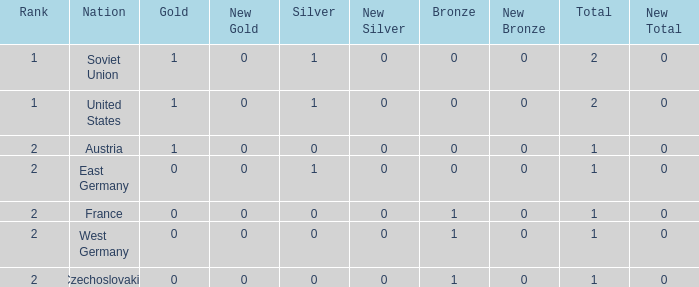What is the highest rank of Austria, which had less than 0 silvers? None. 